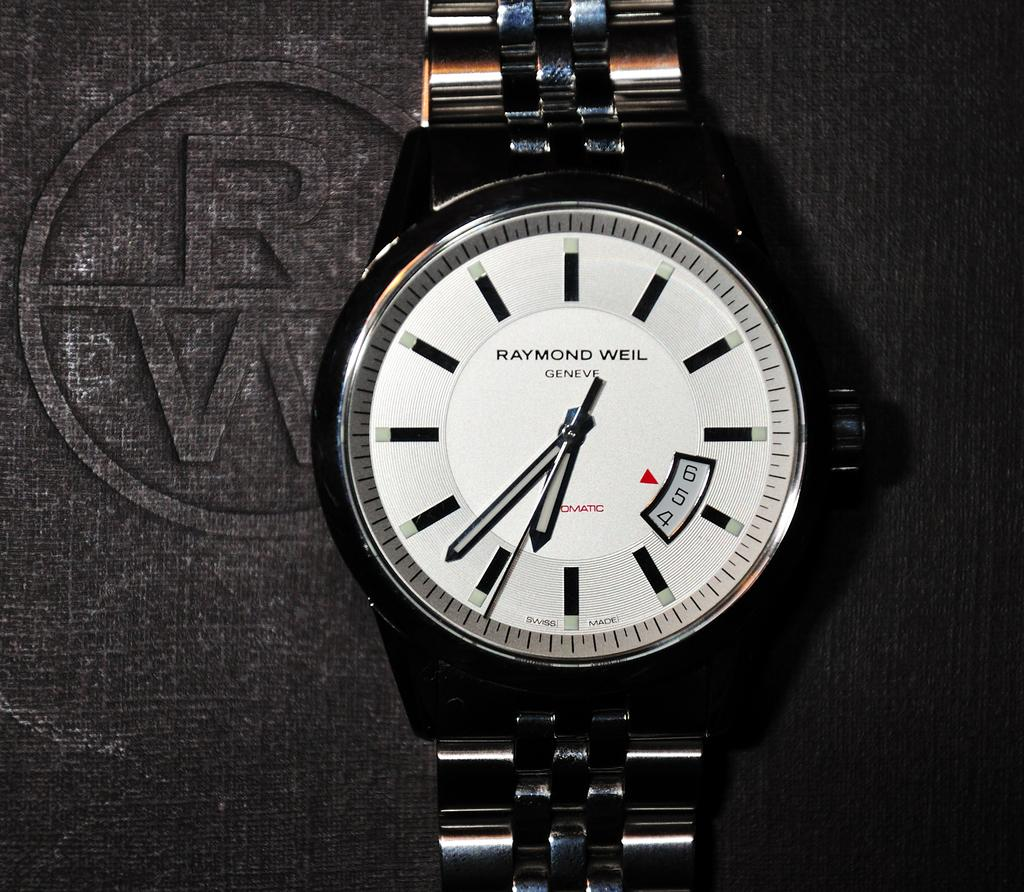Provide a one-sentence caption for the provided image. A Raymond Weil watch shows the luxury of man. 